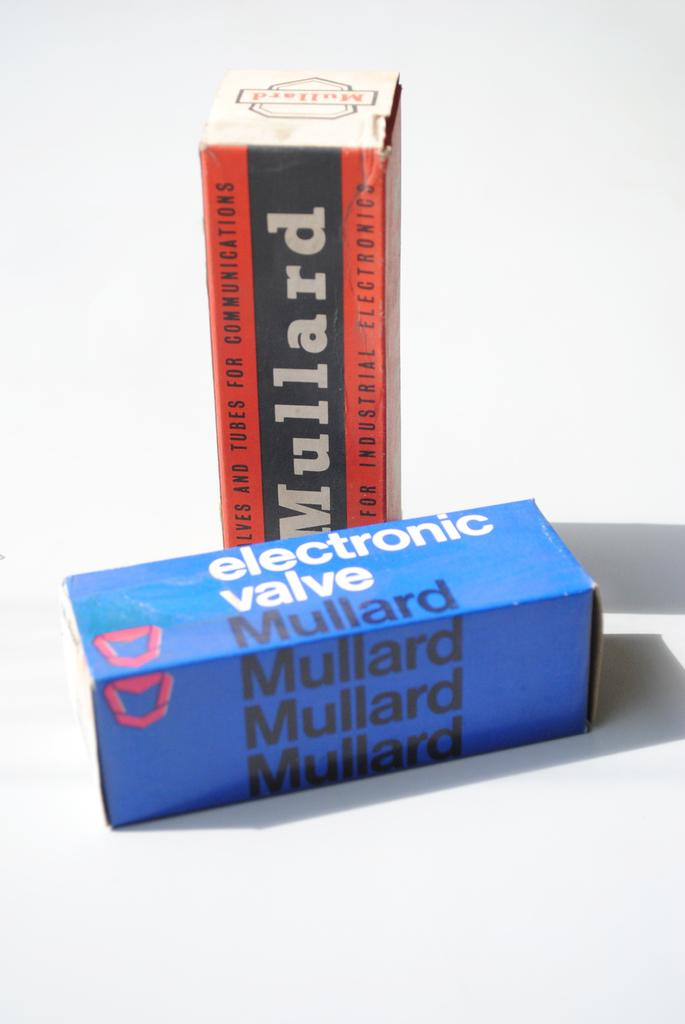Provide a one-sentence caption for the provided image. new boxes of electronic valve and mullard box. 